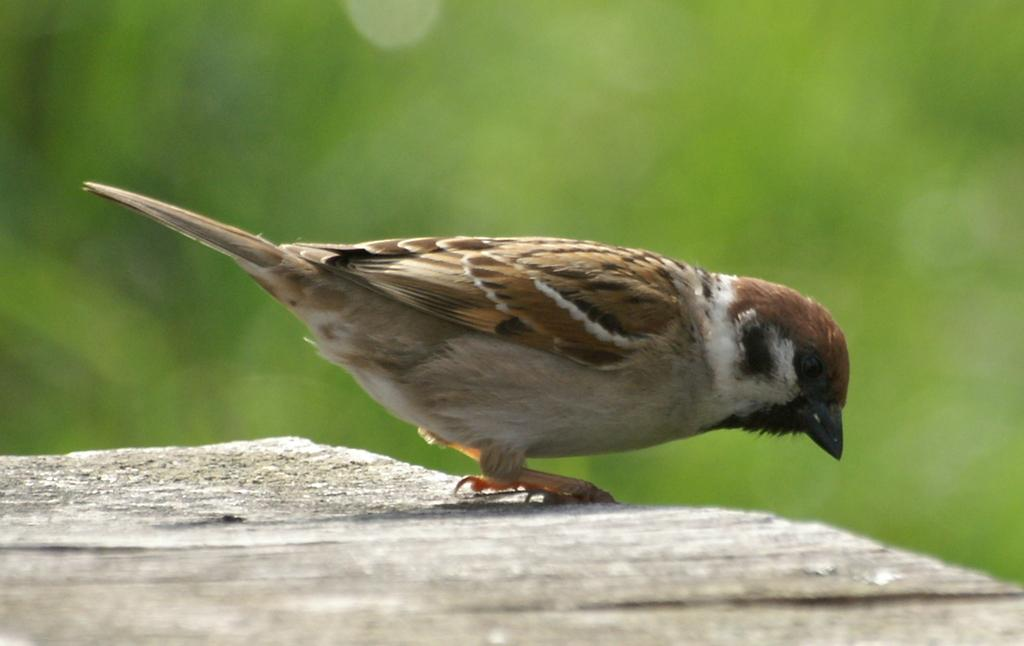What type of animal can be seen in the image? There is a bird in the image. Where is the bird located? The bird is on the surface of something, likely water. Can you describe the background of the image? The background of the image has a blurred view. What color is present in the image? The color green is present in the image. Are there any tables or plots visible in the image? There is no table or plot present in the image. Can you see any cobwebs in the image? There is no cobweb present in the image. 